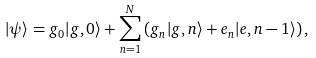Convert formula to latex. <formula><loc_0><loc_0><loc_500><loc_500>| \psi \rangle = g _ { 0 } | g , 0 \rangle + \sum _ { n = 1 } ^ { N } \left ( g _ { n } | g , n \rangle + e _ { n } | e , n - 1 \rangle \right ) ,</formula> 